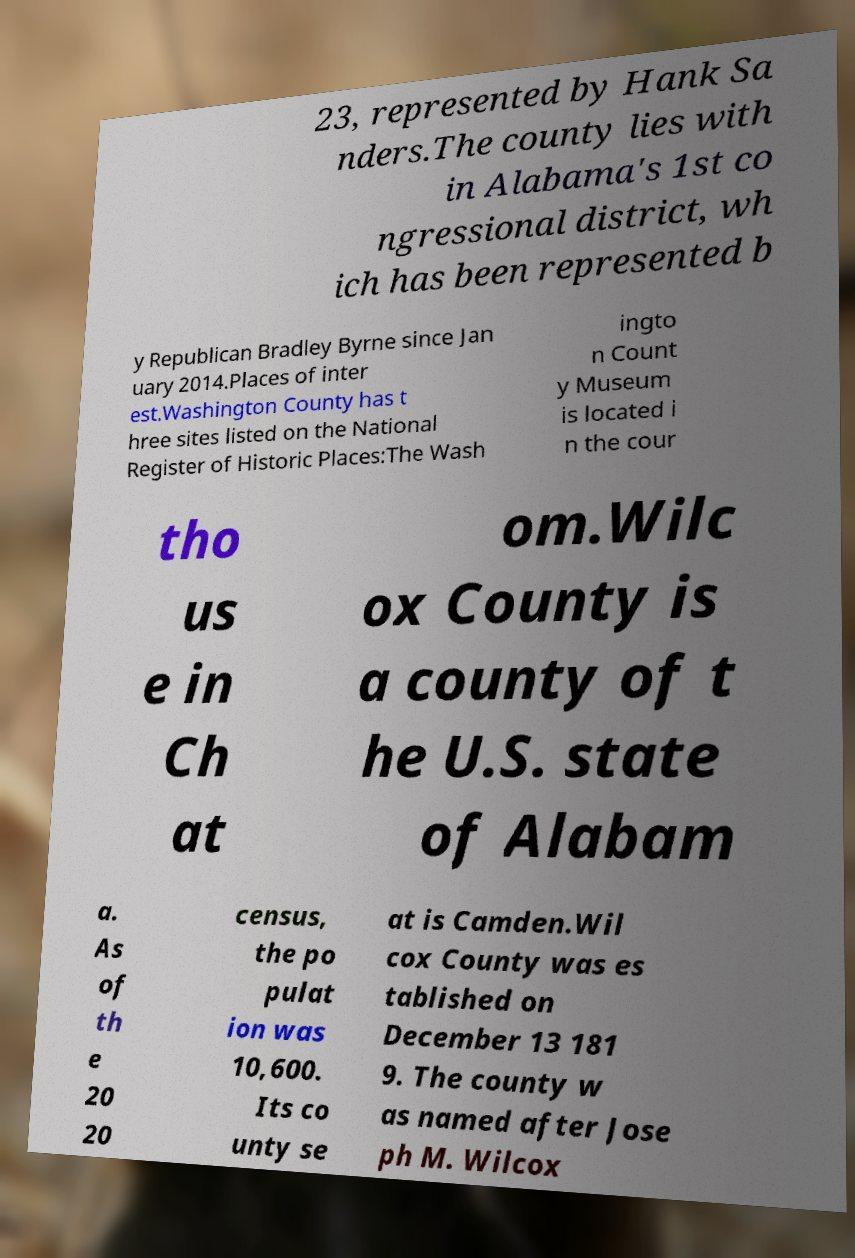Can you accurately transcribe the text from the provided image for me? 23, represented by Hank Sa nders.The county lies with in Alabama's 1st co ngressional district, wh ich has been represented b y Republican Bradley Byrne since Jan uary 2014.Places of inter est.Washington County has t hree sites listed on the National Register of Historic Places:The Wash ingto n Count y Museum is located i n the cour tho us e in Ch at om.Wilc ox County is a county of t he U.S. state of Alabam a. As of th e 20 20 census, the po pulat ion was 10,600. Its co unty se at is Camden.Wil cox County was es tablished on December 13 181 9. The county w as named after Jose ph M. Wilcox 